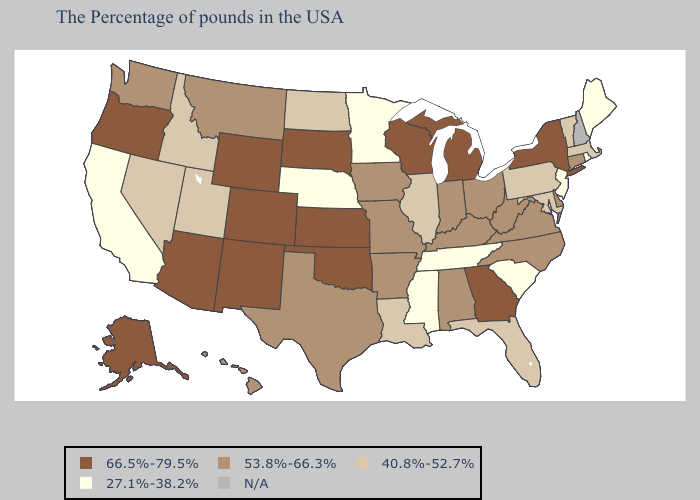Does Idaho have the highest value in the USA?
Give a very brief answer. No. What is the lowest value in the Northeast?
Concise answer only. 27.1%-38.2%. Which states have the lowest value in the West?
Write a very short answer. California. Name the states that have a value in the range 40.8%-52.7%?
Short answer required. Massachusetts, Vermont, Maryland, Pennsylvania, Florida, Illinois, Louisiana, North Dakota, Utah, Idaho, Nevada. What is the value of New Jersey?
Give a very brief answer. 27.1%-38.2%. Which states hav the highest value in the MidWest?
Short answer required. Michigan, Wisconsin, Kansas, South Dakota. What is the highest value in states that border Washington?
Answer briefly. 66.5%-79.5%. How many symbols are there in the legend?
Keep it brief. 5. Among the states that border Florida , which have the lowest value?
Write a very short answer. Alabama. Name the states that have a value in the range 66.5%-79.5%?
Keep it brief. New York, Georgia, Michigan, Wisconsin, Kansas, Oklahoma, South Dakota, Wyoming, Colorado, New Mexico, Arizona, Oregon, Alaska. What is the value of Florida?
Write a very short answer. 40.8%-52.7%. 